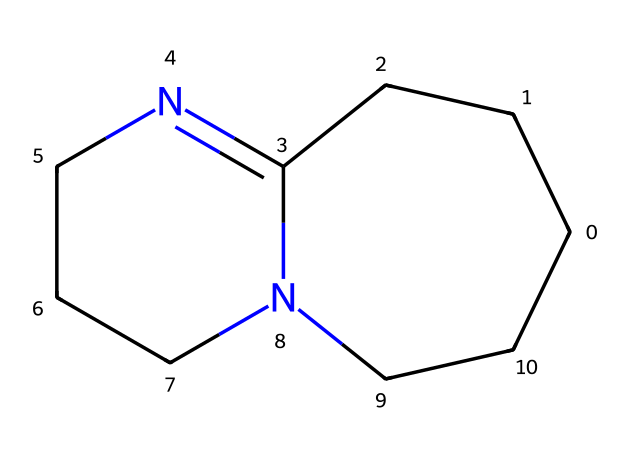What is the total number of nitrogen atoms in DBU? The SMILES representation includes "N" to signify nitrogen atoms. By counting the "N" in the structure, we find there are two nitrogen atoms present.
Answer: two How many carbon atoms are in the structure of DBU? The SMILES representation includes "C" to identify carbon atoms. By counting the "C," we find there are 11 carbon atoms in total within the structure.
Answer: eleven What type of chemical bonding primarily occurs in the structure of DBU? The SMILES representation indicates the connections between atoms with standard bonds. Carbon atoms are involved in single and double bonds with nitrogen, suggesting that the primary type of bonding is covalent bonding.
Answer: covalent Which part of the DBU structure contributes to its strong basicity? The nitrogen atoms are key contributors to basicity. They have lone pairs that can accept protons, which is characteristic of superbases like DBU.
Answer: nitrogen atoms How many rings are present in the chemical structure of DBU? Examining the structure, we see that it forms a bicyclic compound, which indicates that there are two rings (following the definition of bicyclic).
Answer: two What is the IUPAC name for the chemical represented by the SMILES? The IUPAC name assigned to this compound based on its structure and functional groups is 1,8-diazabicyclo[5.4.0]undec-7-ene. This name describes the bicyclic nature and specific arrangement of atoms.
Answer: 1,8-diazabicyclo[5.4.0]undec-7-ene 